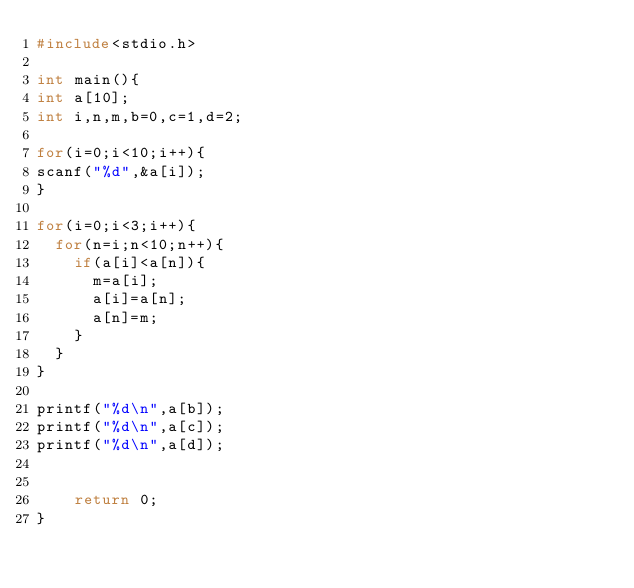<code> <loc_0><loc_0><loc_500><loc_500><_C_>#include<stdio.h>

int main(){
int a[10];
int i,n,m,b=0,c=1,d=2;

for(i=0;i<10;i++){
scanf("%d",&a[i]);
}

for(i=0;i<3;i++){
	for(n=i;n<10;n++){
		if(a[i]<a[n]){
			m=a[i];
			a[i]=a[n];
			a[n]=m;
		}
	}
}
	
printf("%d\n",a[b]);
printf("%d\n",a[c]);
printf("%d\n",a[d]);

		
    return 0;
}</code> 